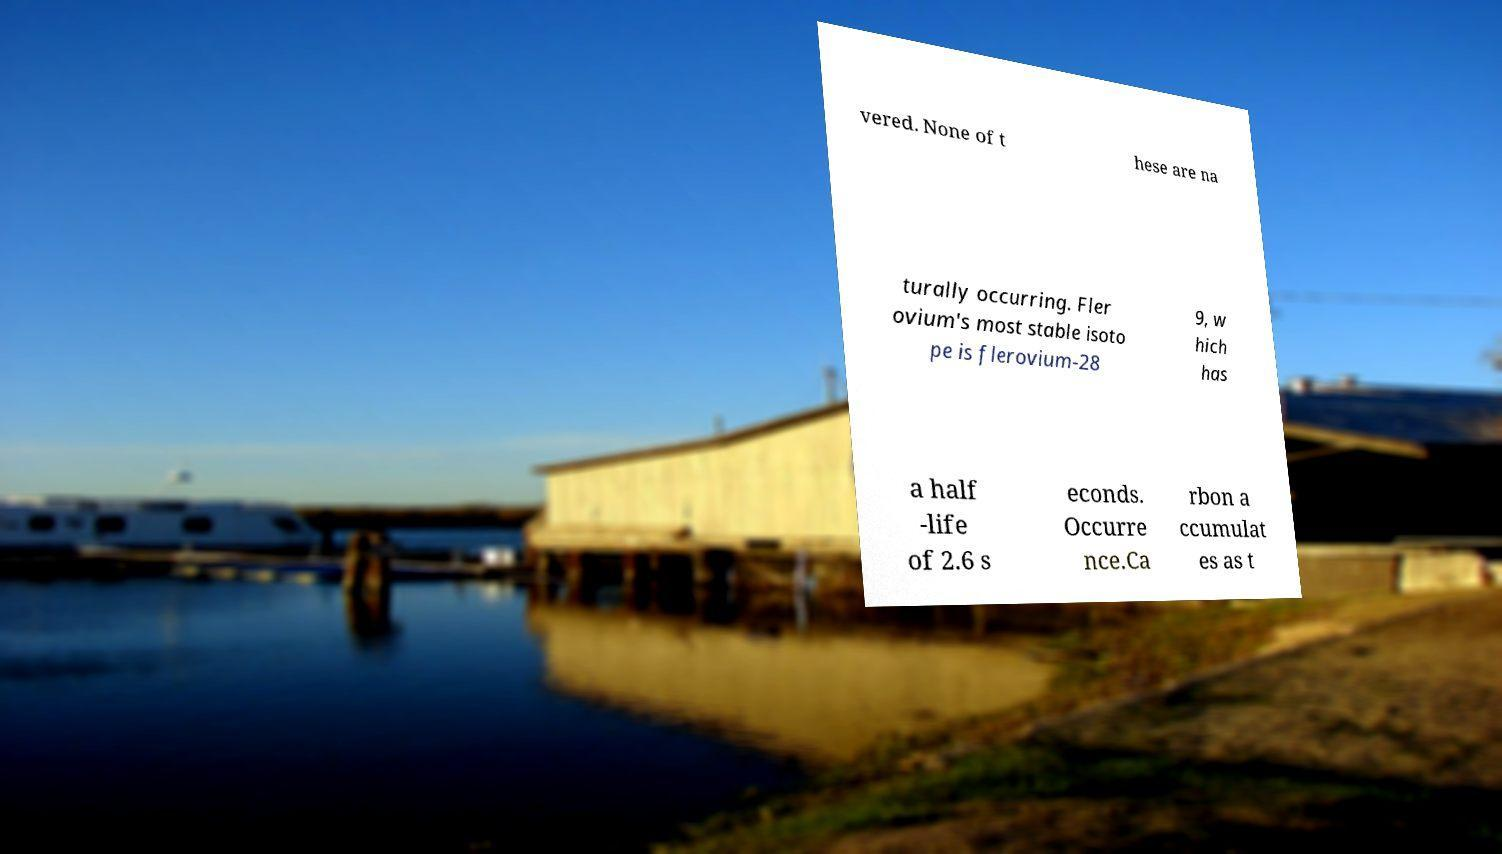Please read and relay the text visible in this image. What does it say? vered. None of t hese are na turally occurring. Fler ovium's most stable isoto pe is flerovium-28 9, w hich has a half -life of 2.6 s econds. Occurre nce.Ca rbon a ccumulat es as t 